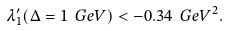Convert formula to latex. <formula><loc_0><loc_0><loc_500><loc_500>\lambda _ { 1 } ^ { \prime } ( \Delta = 1 { \mathrm \ G e V } ) < - 0 . 3 4 { \mathrm \ G e V } ^ { 2 } .</formula> 